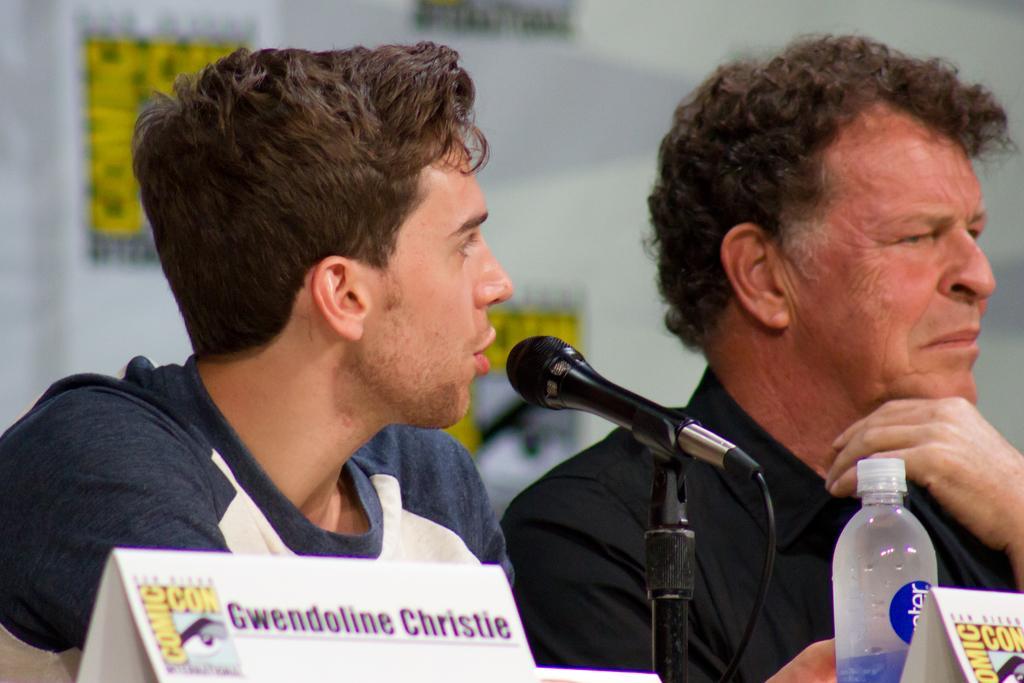Describe this image in one or two sentences. In the image we can see two persons were sitting. In front we can see microphone and water bottle. In the background there is a wall. 